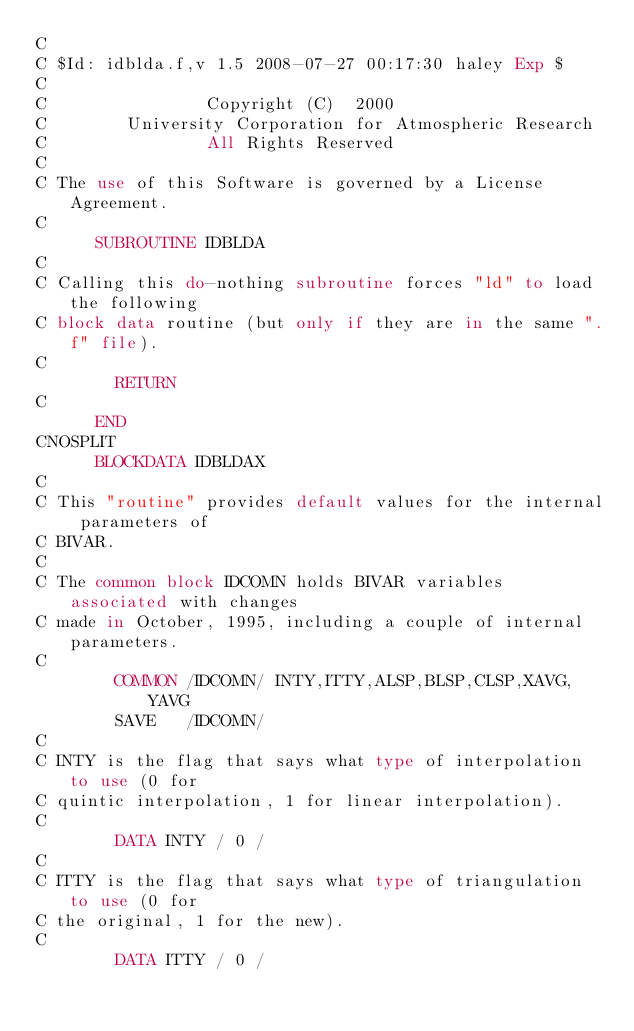Convert code to text. <code><loc_0><loc_0><loc_500><loc_500><_FORTRAN_>C
C $Id: idblda.f,v 1.5 2008-07-27 00:17:30 haley Exp $
C                                                                      
C                Copyright (C)  2000
C        University Corporation for Atmospheric Research
C                All Rights Reserved
C
C The use of this Software is governed by a License Agreement.
C
      SUBROUTINE IDBLDA
C
C Calling this do-nothing subroutine forces "ld" to load the following
C block data routine (but only if they are in the same ".f" file).
C
        RETURN
C
      END
CNOSPLIT
      BLOCKDATA IDBLDAX
C
C This "routine" provides default values for the internal parameters of
C BIVAR.
C
C The common block IDCOMN holds BIVAR variables associated with changes
C made in October, 1995, including a couple of internal parameters.
C
        COMMON /IDCOMN/ INTY,ITTY,ALSP,BLSP,CLSP,XAVG,YAVG
        SAVE   /IDCOMN/
C
C INTY is the flag that says what type of interpolation to use (0 for
C quintic interpolation, 1 for linear interpolation).
C
        DATA INTY / 0 /
C
C ITTY is the flag that says what type of triangulation to use (0 for
C the original, 1 for the new).
C
        DATA ITTY / 0 /</code> 